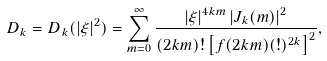<formula> <loc_0><loc_0><loc_500><loc_500>D _ { k } = D _ { k } ( | \xi | ^ { 2 } ) = \sum _ { m = 0 } ^ { \infty } \frac { \left | \xi \right | ^ { 4 k m } \left | J _ { k } ( m ) \right | ^ { 2 } } { ( 2 k m ) ! \left [ f ( 2 k m ) ( ! ) ^ { 2 k } \right ] ^ { 2 } } ,</formula> 